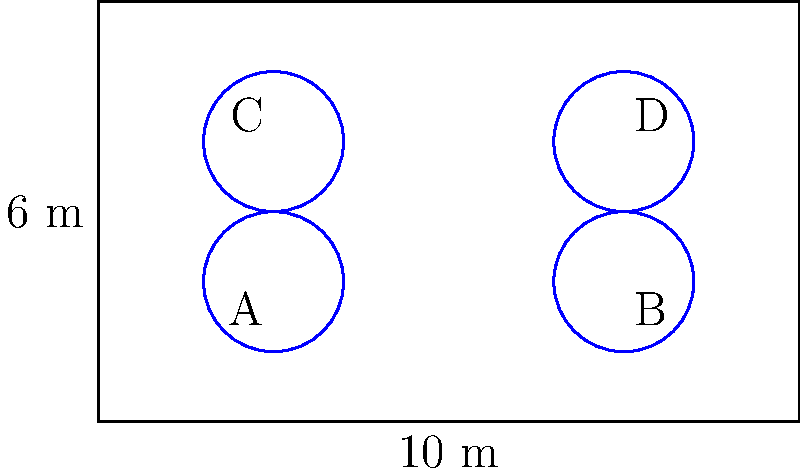In your rectangular cattle field measuring 10 m by 6 m, you've decided to install circular feeding stations to optimize your livestock's access to feed and integrate insect farming. The feeding stations are arranged in a grid pattern with 4 stations, as shown in the diagram. If the radius of each feeding station is 1 m, what is the minimum distance between the centers of any two adjacent feeding stations? To find the minimum distance between the centers of any two adjacent feeding stations, we can follow these steps:

1) First, let's identify the possible adjacent pairs:
   - Horizontally: A-B and C-D
   - Vertically: A-C and B-D

2) The field is 10 m wide and has two columns of feeding stations. To find the horizontal distance between centers:
   $$ \text{Horizontal distance} = 10 \text{ m} \div 2 = 5 \text{ m} $$

3) The field is 6 m long and has two rows of feeding stations. To find the vertical distance between centers:
   $$ \text{Vertical distance} = 6 \text{ m} \div 2 = 3 \text{ m} $$

4) The minimum distance will be the smaller of these two values.

5) Therefore, the minimum distance between the centers of any two adjacent feeding stations is 3 m.

This arrangement ensures optimal spacing for your cattle to access feed and for integrating insect farming, maximizing the use of space in your field.
Answer: 3 m 